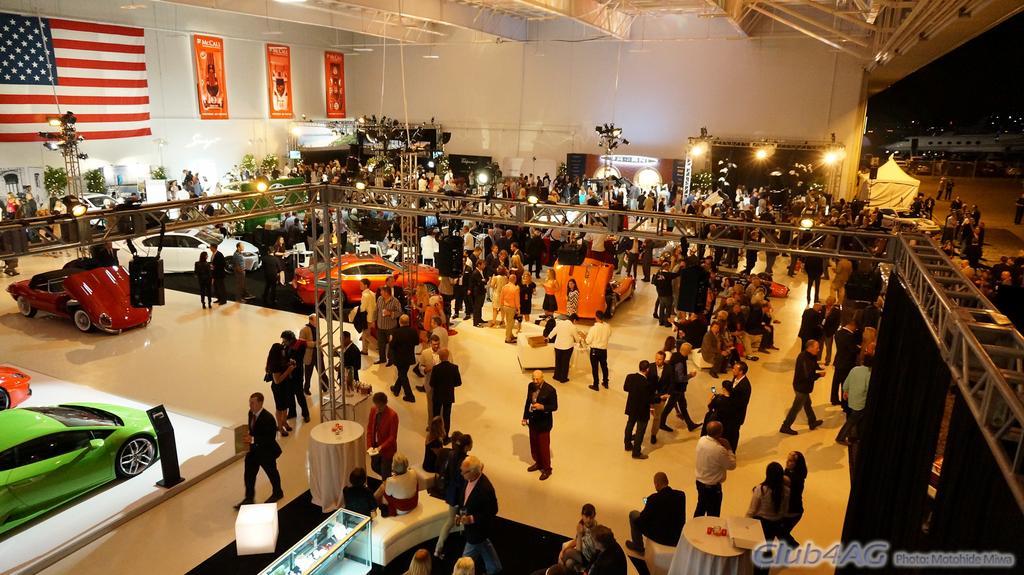How would you summarize this image in a sentence or two? In the foreground, I can see vehicles, tables, sofa chairs, metal objects and a crowd on the floor. In the background, I can see posts on a wall, flag, lights and a rooftop. On the right, I can see an aircraft on the road. This picture might be taken in a hall. 